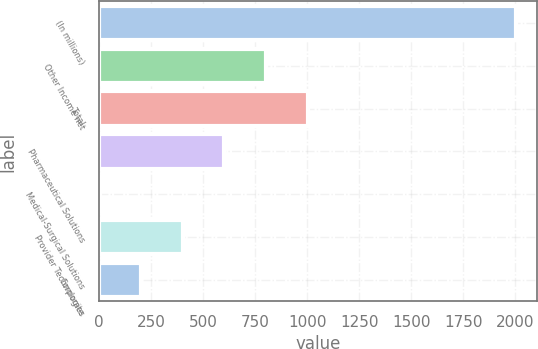<chart> <loc_0><loc_0><loc_500><loc_500><bar_chart><fcel>(In millions)<fcel>Other Income net<fcel>Total<fcel>Pharmaceutical Solutions<fcel>Medical-Surgical Solutions<fcel>Provider Technologies<fcel>Corporate<nl><fcel>2003<fcel>802.58<fcel>1002.65<fcel>602.51<fcel>2.3<fcel>402.44<fcel>202.37<nl></chart> 